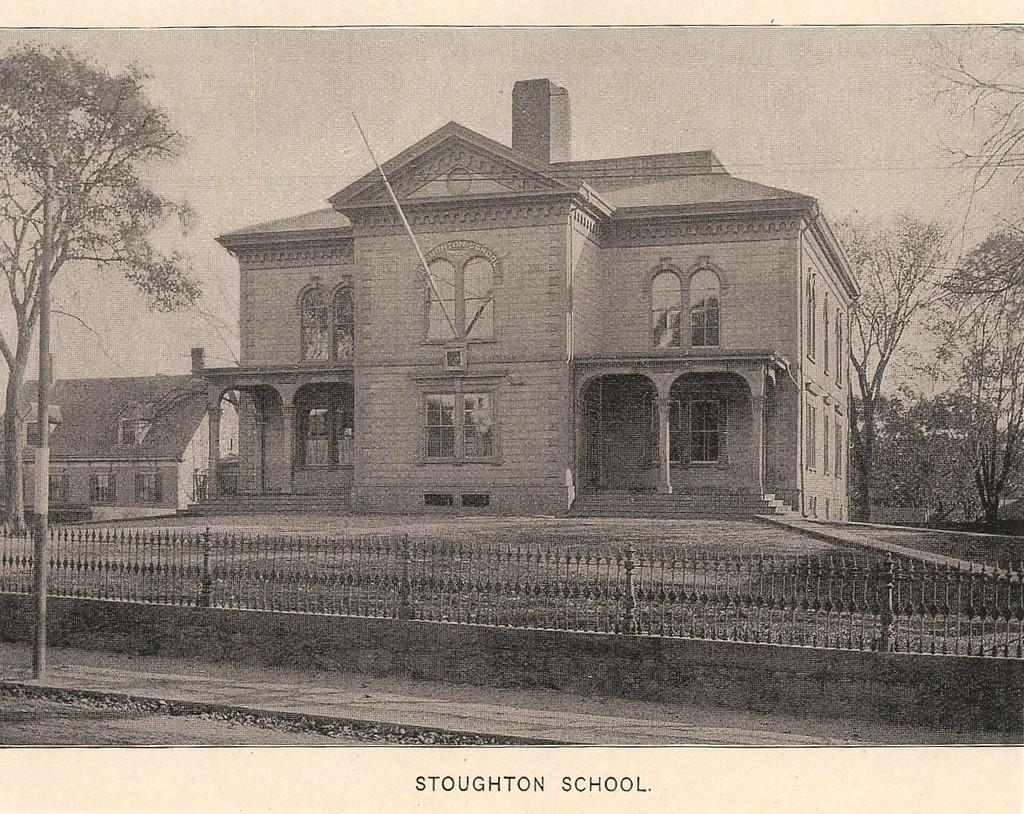What type of structure can be seen in the image? There is a fence in the image. What else is present in the image besides the fence? There is a pole, trees, and buildings in the image. Can you describe the vegetation in the image? There are trees in the image. What type of man-made structures can be seen in the image? There are buildings in the image. How many toads are sitting on the fence in the image? There are no toads present in the image. What historical event is depicted in the image? The image does not depict any historical event; it features a fence, a pole, trees, and buildings. 